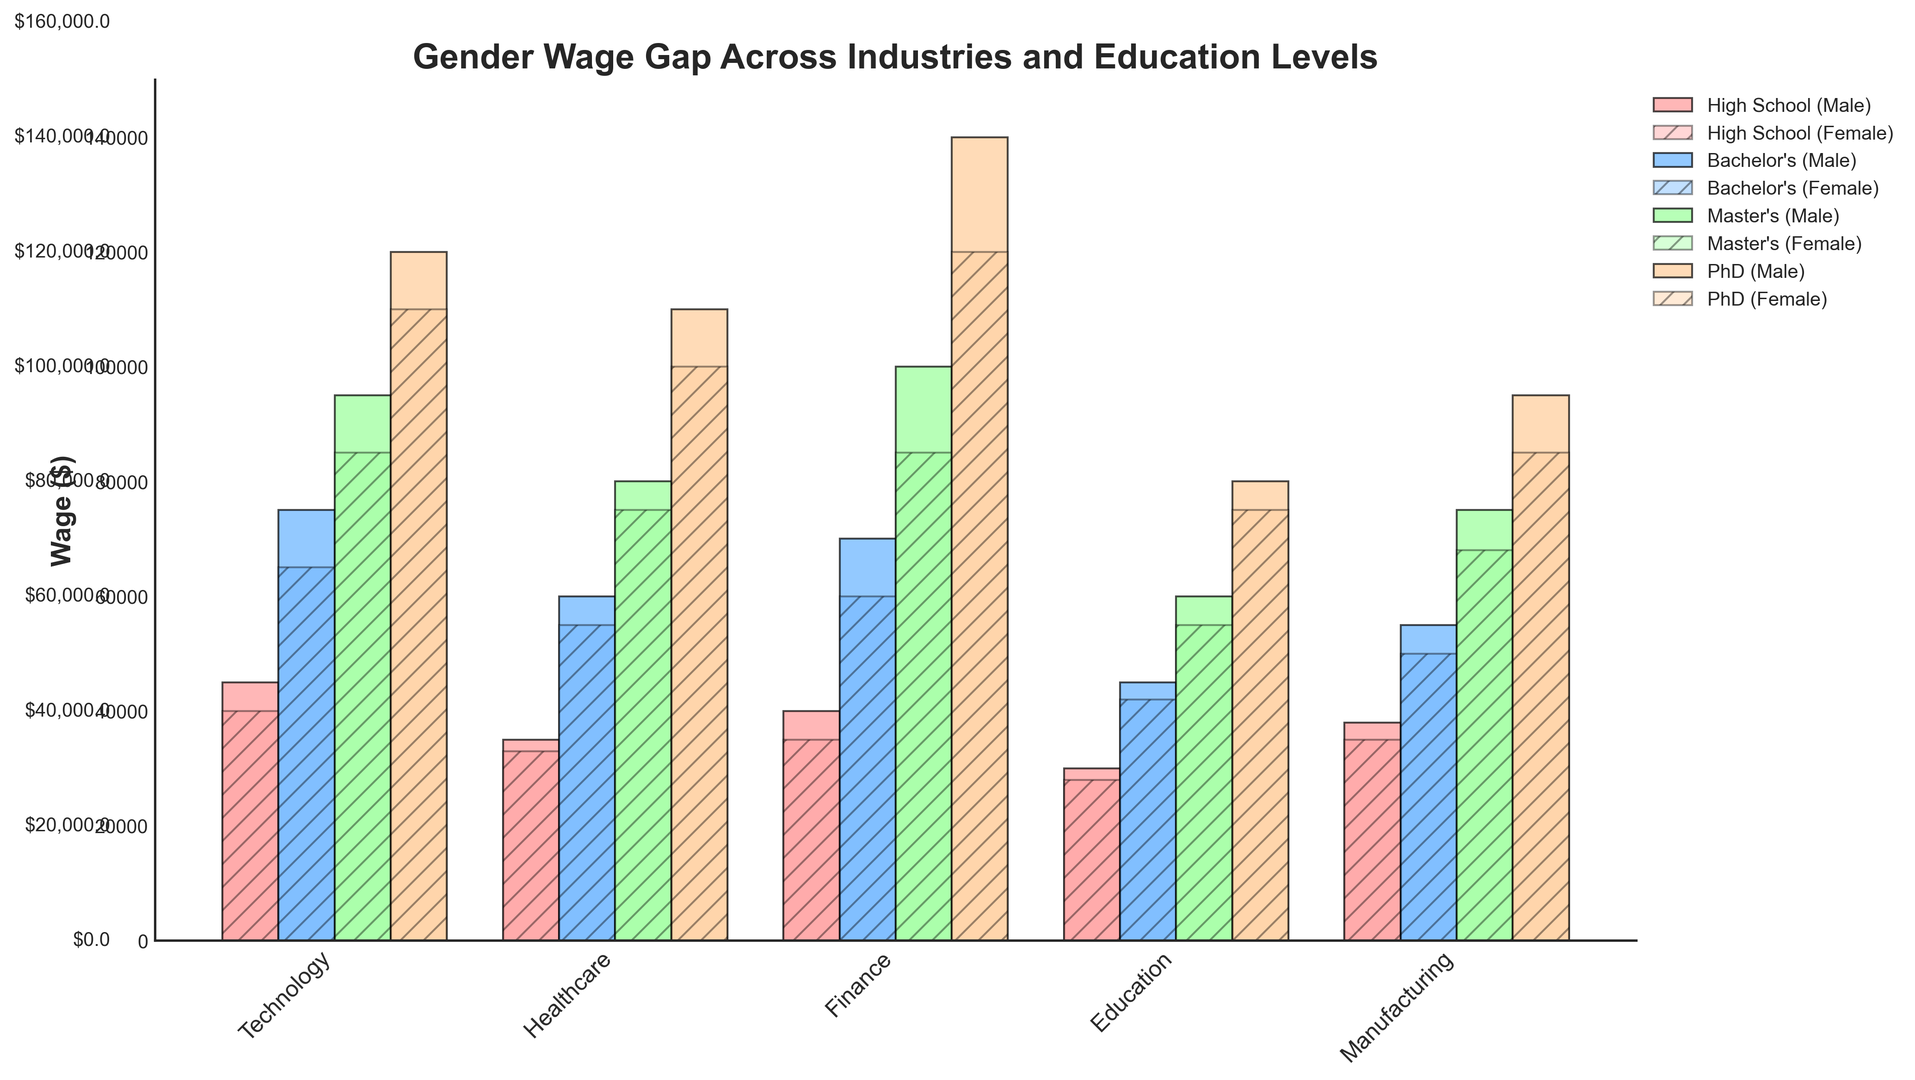What is the wage difference between males and females with a Bachelor's degree in the Finance industry? To find the wage difference, look at the bars representing males and females with a Bachelor's degree in the Finance industry. The male wage is $70,000, and the female wage is $60,000. Subtract the female wage from the male wage: $70,000 - $60,000.
Answer: $10,000 Which industry shows the smallest wage gap between males and females with a PhD? Compare the heights of the bars for males and females with a PhD across all industries. The smallest difference appears in the Healthcare industry, where males earn $110,000, and females earn $100,000, resulting in a $10,000 difference.
Answer: Healthcare Which education level shows the largest wage gap in the Technology industry, and what is the difference? Look at the wage differences at each education level in the Technology industry. Compare the differences: High School ($5,000), Bachelor's ($10,000), Master's ($10,000), PhD ($10,000). The largest gaps are at the Bachelor's, Master's, and PhD levels.
Answer: Bachelor's/Master's/PhD, $10,000 What's the average male wage across all industries and education levels? Sum the male wages across all data points and divide by the total number of data points. ($45,000 + $75,000 + $95,000 + $120,000 + $35,000 + $60,000 + $80,000 + $110,000 + $40,000 + $70,000 + $100,000 + $140,000 + $30,000 + $45,000 + $60,000 + $80,000 + $38,000 + $55,000 + $75,000 + $95,000) / 20 = $71,750.
Answer: $71,750 Which industry has the most significant visual difference in bar heights between males and females at the Master's level? Compare the heights of the bars for the males and females at the Master's level across all industries. The Finance industry shows the largest visual difference, where males earn $100,000 and females earn $85,000.
Answer: Finance What is the total wage for males with a High School education across all industries? Sum the male wages with a High School education across all industries: $45,000 (Technology) + $35,000 (Healthcare) + $40,000 (Finance) + $30,000 (Education) + $38,000 (Manufacturing) = $188,000.
Answer: $188,000 Which industry shows the highest wage for females with a Bachelor's degree? Identify the highest bar for females with a Bachelor's degree across all industries. The Technology industry has the highest wage, where females earn $65,000.
Answer: Technology How does the average female wage in the Healthcare industry compare to the average male wage in the same industry? Calculate the average female wage: ($33,000 + $55,000 + $75,000 + $100,000) / 4 = $65,750. Calculate the average male wage: ($35,000 + $60,000 + $80,000 + $110,000) / 4 = $71,250. Compare the two averages: $65,750 (female) vs. $71,250 (male).
Answer: Females earn on average $5,500 less than males Which industry has the highest wage for males with a PhD, and what is the wage difference with females in the same industry? Find the industry with the highest male wage for a PhD, which is Finance at $140,000. The corresponding female wage is $120,000. The difference is $140,000 - $120,000.
Answer: Finance, $20,000 